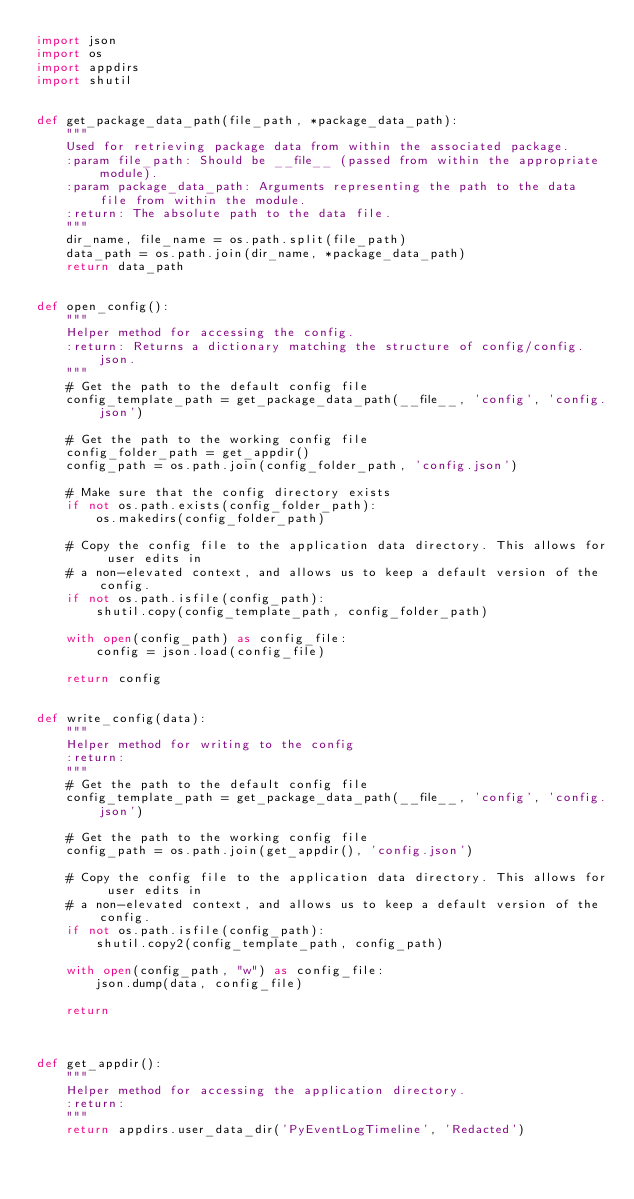<code> <loc_0><loc_0><loc_500><loc_500><_Python_>import json
import os
import appdirs
import shutil


def get_package_data_path(file_path, *package_data_path):
    """
    Used for retrieving package data from within the associated package.
    :param file_path: Should be __file__ (passed from within the appropriate module).
    :param package_data_path: Arguments representing the path to the data file from within the module.
    :return: The absolute path to the data file.
    """
    dir_name, file_name = os.path.split(file_path)
    data_path = os.path.join(dir_name, *package_data_path)
    return data_path


def open_config():
    """
    Helper method for accessing the config.
    :return: Returns a dictionary matching the structure of config/config.json.
    """
    # Get the path to the default config file
    config_template_path = get_package_data_path(__file__, 'config', 'config.json')

    # Get the path to the working config file
    config_folder_path = get_appdir()
    config_path = os.path.join(config_folder_path, 'config.json')

    # Make sure that the config directory exists
    if not os.path.exists(config_folder_path):
        os.makedirs(config_folder_path)

    # Copy the config file to the application data directory. This allows for user edits in
    # a non-elevated context, and allows us to keep a default version of the config.
    if not os.path.isfile(config_path):
        shutil.copy(config_template_path, config_folder_path)

    with open(config_path) as config_file:
        config = json.load(config_file)

    return config


def write_config(data):
    """
    Helper method for writing to the config
    :return:
    """
    # Get the path to the default config file
    config_template_path = get_package_data_path(__file__, 'config', 'config.json')

    # Get the path to the working config file
    config_path = os.path.join(get_appdir(), 'config.json')

    # Copy the config file to the application data directory. This allows for user edits in
    # a non-elevated context, and allows us to keep a default version of the config.
    if not os.path.isfile(config_path):
        shutil.copy2(config_template_path, config_path)

    with open(config_path, "w") as config_file:
        json.dump(data, config_file)

    return



def get_appdir():
    """
    Helper method for accessing the application directory.
    :return:
    """
    return appdirs.user_data_dir('PyEventLogTimeline', 'Redacted')
</code> 